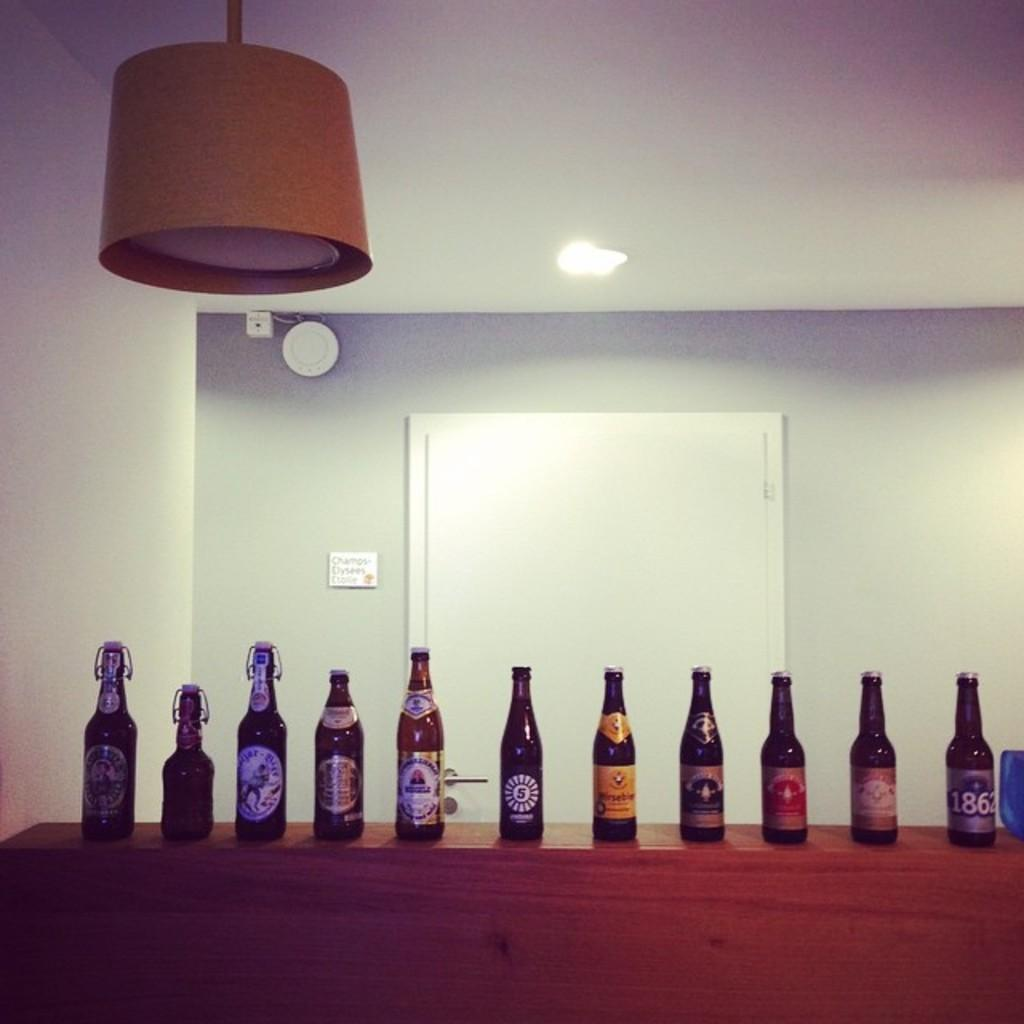<image>
Relay a brief, clear account of the picture shown. Several bottles of beer are neatly lined up n a shelf, the one on the far end has 1862 on the label 